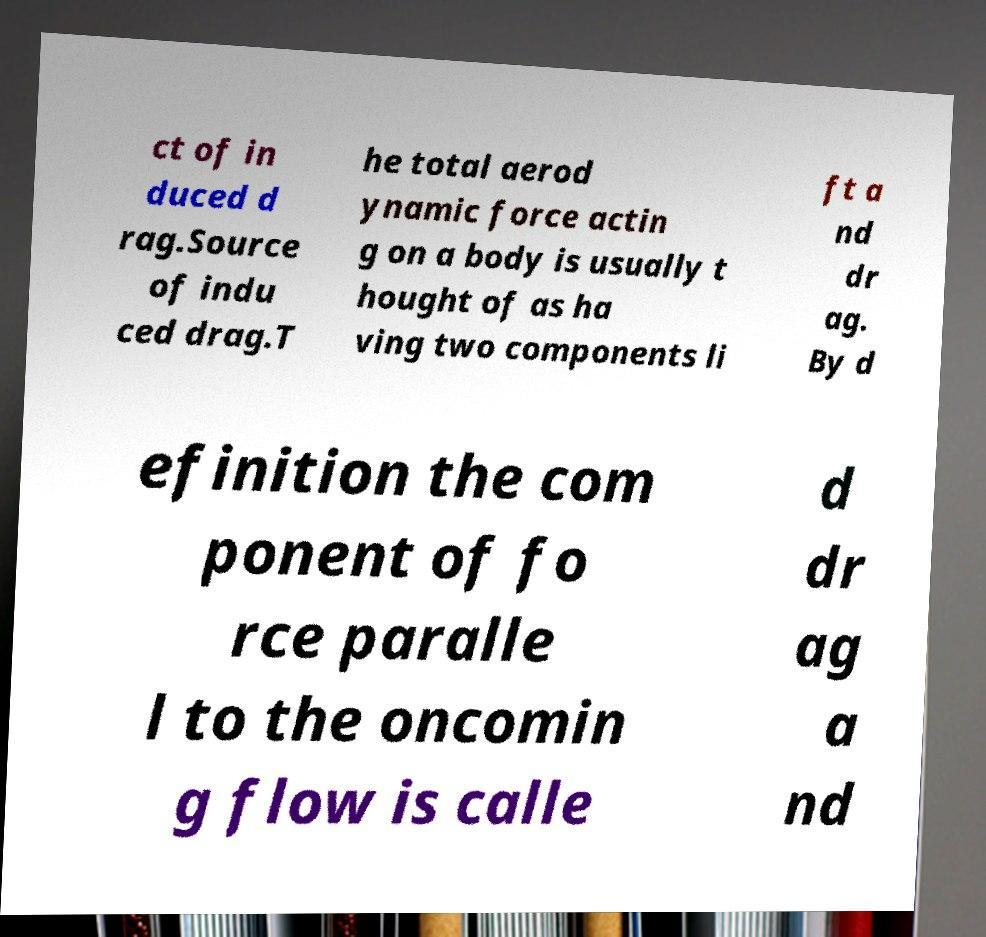Could you assist in decoding the text presented in this image and type it out clearly? ct of in duced d rag.Source of indu ced drag.T he total aerod ynamic force actin g on a body is usually t hought of as ha ving two components li ft a nd dr ag. By d efinition the com ponent of fo rce paralle l to the oncomin g flow is calle d dr ag a nd 